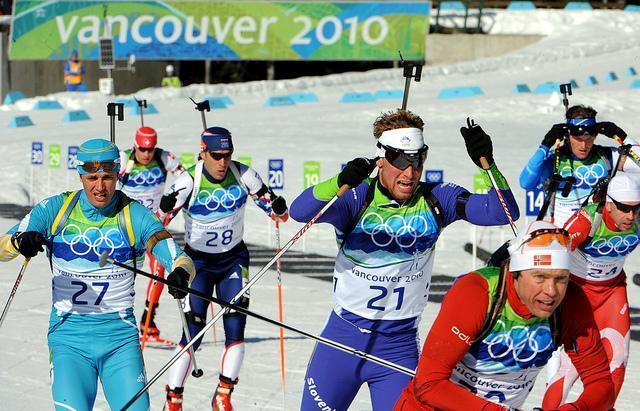How many persons have glasses?
Give a very brief answer. 7. How many people are wearing gloves?
Give a very brief answer. 7. How many people are visible?
Give a very brief answer. 7. 